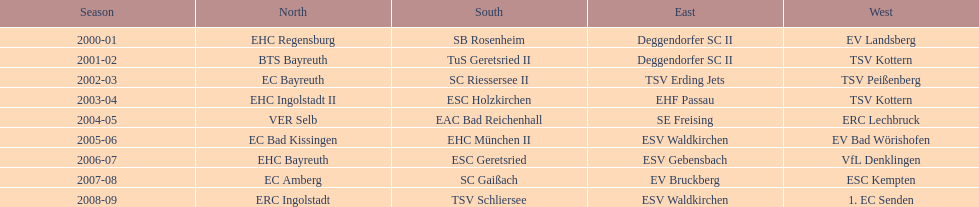Which squads have been victorious in the bavarian ice hockey leagues from 2000 to 2009? EHC Regensburg, SB Rosenheim, Deggendorfer SC II, EV Landsberg, BTS Bayreuth, TuS Geretsried II, TSV Kottern, EC Bayreuth, SC Riessersee II, TSV Erding Jets, TSV Peißenberg, EHC Ingolstadt II, ESC Holzkirchen, EHF Passau, TSV Kottern, VER Selb, EAC Bad Reichenhall, SE Freising, ERC Lechbruck, EC Bad Kissingen, EHC München II, ESV Waldkirchen, EV Bad Wörishofen, EHC Bayreuth, ESC Geretsried, ESV Gebensbach, VfL Denklingen, EC Amberg, SC Gaißach, EV Bruckberg, ESC Kempten, ERC Ingolstadt, TSV Schliersee, ESV Waldkirchen, 1. EC Senden. Which of these triumphant squads have conquered the north? EHC Regensburg, BTS Bayreuth, EC Bayreuth, EHC Ingolstadt II, VER Selb, EC Bad Kissingen, EHC Bayreuth, EC Amberg, ERC Ingolstadt. Which of the northern winning squads prevailed in the 2000/2001 season? EHC Regensburg. 